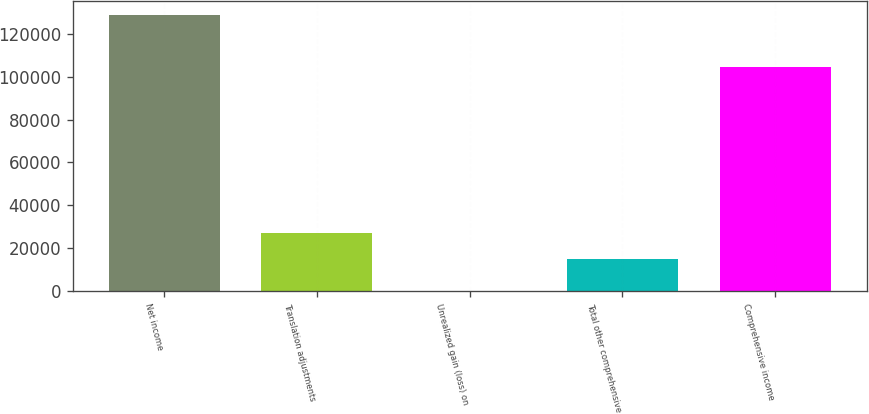Convert chart to OTSL. <chart><loc_0><loc_0><loc_500><loc_500><bar_chart><fcel>Net income<fcel>Translation adjustments<fcel>Unrealized gain (loss) on<fcel>Total other comprehensive<fcel>Comprehensive income<nl><fcel>129042<fcel>27073.7<fcel>42<fcel>14977<fcel>104849<nl></chart> 